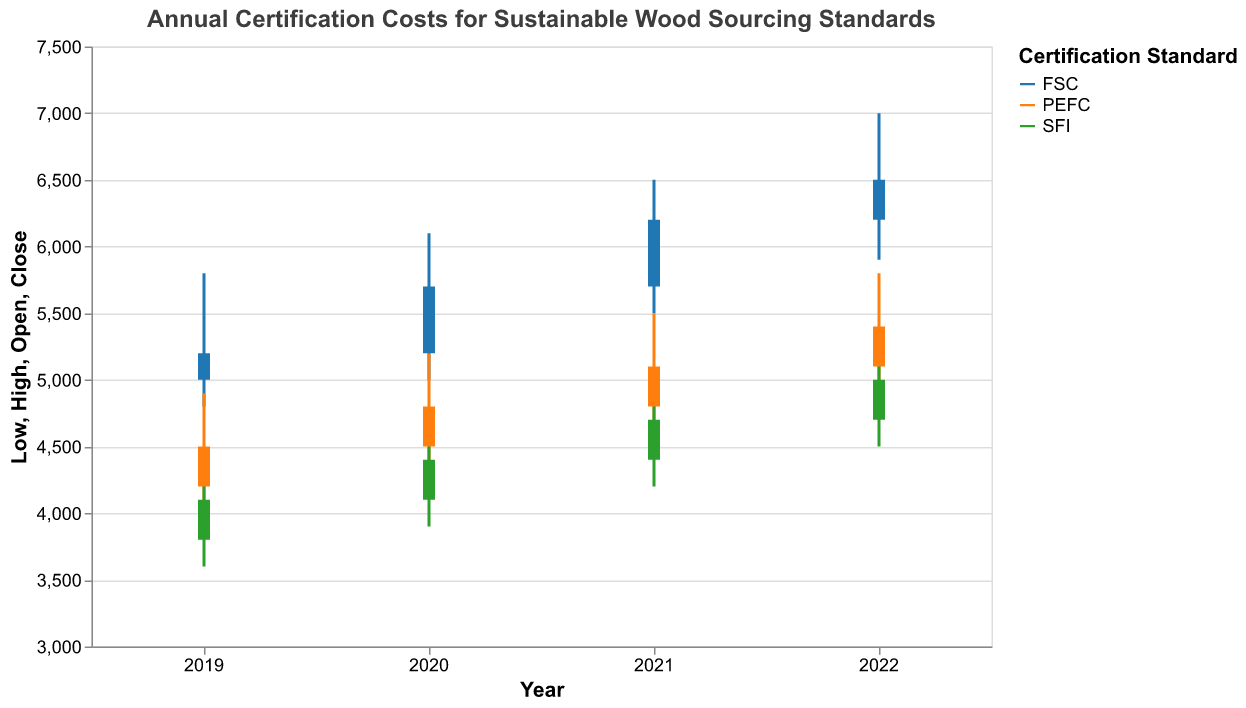What is the title of the chart? The title is located at the top of the chart and is the most prominent text.
Answer: Annual Certification Costs for Sustainable Wood Sourcing Standards Which certification standard had the highest close value in 2022? Look for the close values in 2022 and compare them for FSC, PEFC, and SFI.
Answer: FSC How did the certification cost for PEFC change from 2019 to 2022? Compare the open value in 2019 with the close value in 2022 for PEFC.
Answer: It increased from 4200 to 5400 What was the range of certification costs for SFI in 2021? Look at the low and high values for SFI in 2021 and calculate the range (high - low).
Answer: 700 (4900 - 4200) Out of the three standards, which one showed the most significant increase in the close value from 2019 to 2022? Calculate the difference between the close values in 2019 and 2022 for FSC, PEFC, and SFI, then compare the increments. FSC: 5200 to 6500 (+1300), PEFC: 4500 to 5400 (+900), SFI: 4100 to 5000 (+900).
Answer: FSC What was the opening value for FSC in 2022, and how does it compare to its closing value in 2021? Look at the opening value for FSC in 2022 and the closing value for FSC in 2021, then compare them.
Answer: 6200 is equal to 6200 Which year showed the highest volatility in certification costs for PEFC? Calculate the difference between high and low values for PEFC for each year and compare. 2019: 4900-4000 = 900, 2020: 5200-4300 = 900, 2021: 5500-4600 = 900, 2022: 5800-4900 = 900. All years have the same volatility.
Answer: All years are equal Considering all years and standards, which certification standard had the lowest closing value and what was it? Compare all close values across all years and standards.
Answer: SFI in 2019 (4100) Between 2020 and 2021, which certification standard had the highest increase in its closing value? Calculate the increase in close values from 2020 to 2021 for FSC, PEFC, and SFI. FSC: 5700 to 6200 (+500), PEFC: 4800 to 5100 (+300), SFI: 4400 to 4700 (+300).
Answer: FSC 